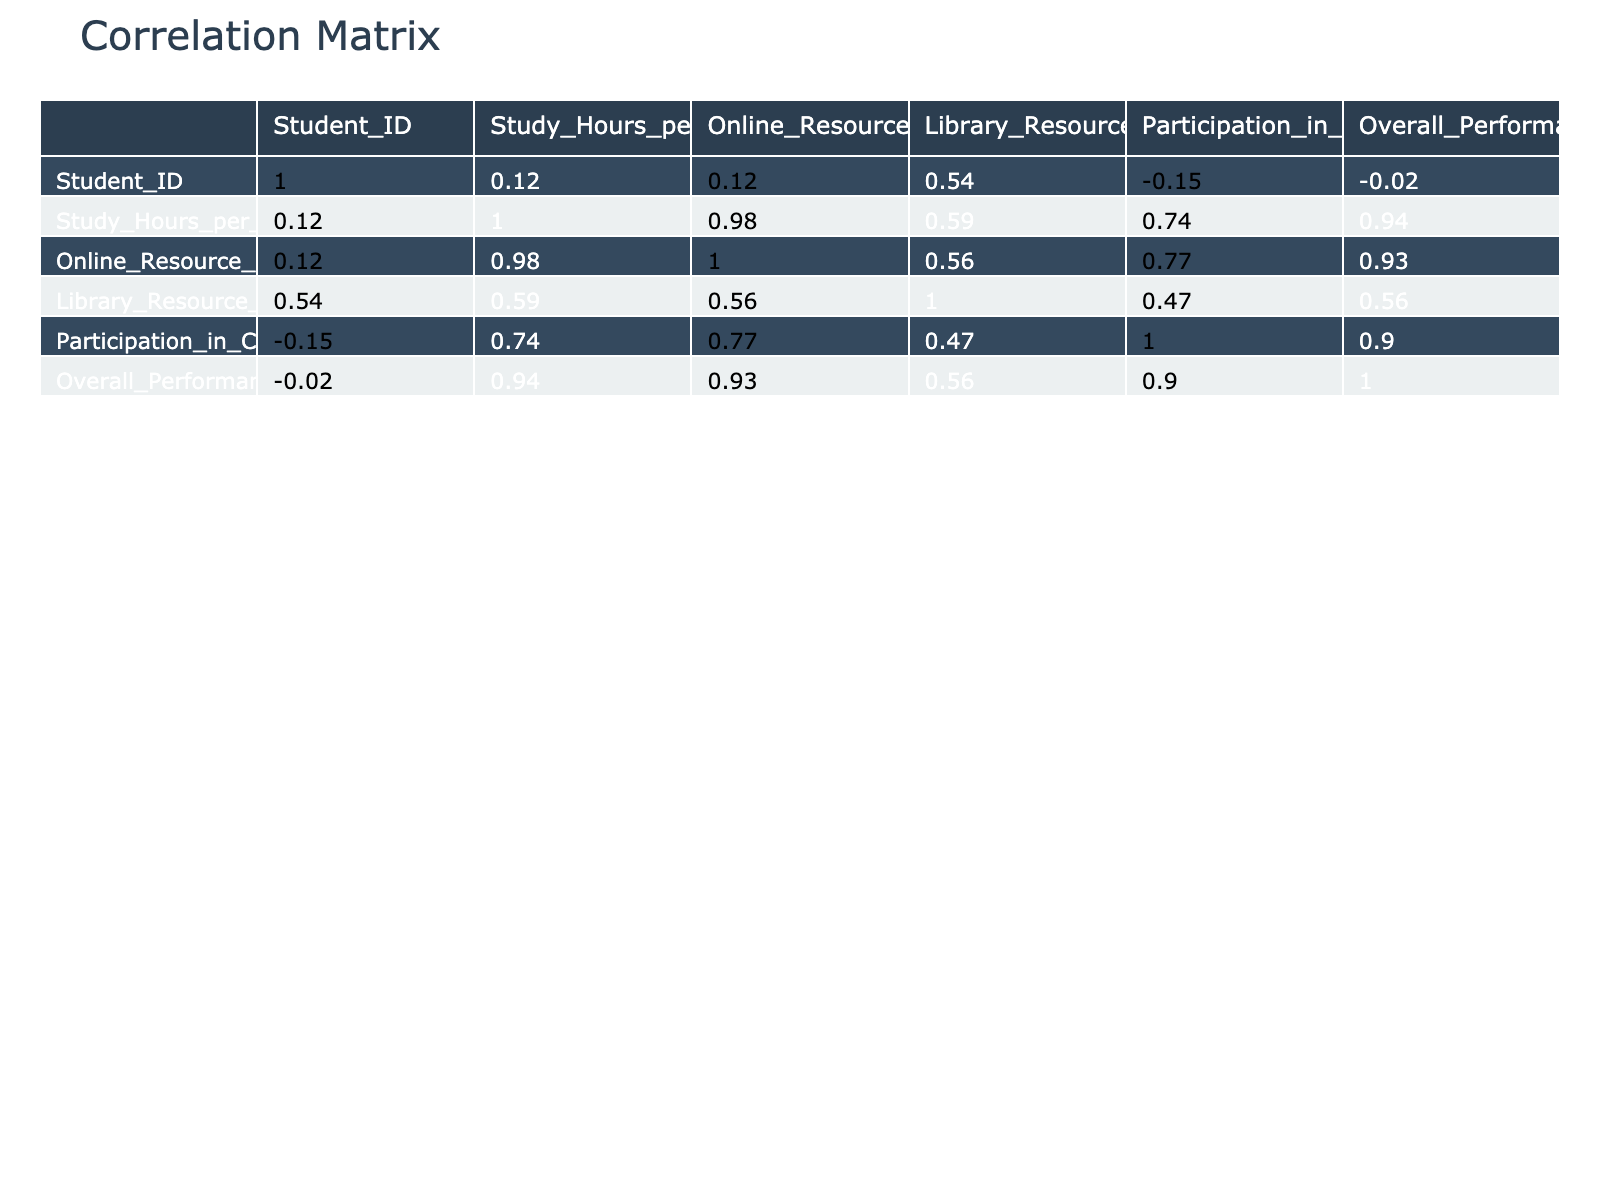What is the correlation coefficient between study hours per week and overall performance score? To find this, look for the specific cell in the correlation table that corresponds to 'Study_Hours_per_Week' and 'Overall_Performance_Score'. The value found there is the correlation coefficient, which quantifies the relationship between these two variables.
Answer: 0.89 What is the median value of online resource utilization among the students? First, we need to identify the values under 'Online_Resource_Utilization': [3, 4, 5, 1, 3, 2, 5, 4, 3, 4]. Sorting these values yields [1, 2, 3, 3, 3, 4, 4, 4, 5, 5]. The median is the average of the two central numbers (3 and 4), which gives us (3 + 4) / 2 = 3.5.
Answer: 3.5 Is there a positive correlation between library resource utilization and overall performance score? To answer this question, we look at the correlation coefficient between 'Library_Resource_Utilization' and 'Overall_Performance_Score'. If the value is greater than 0, it indicates a positive correlation. After reviewing the table, we find this value is 0.85, which is positive.
Answer: Yes Which student had the highest overall performance score, and what was that score? We check the 'Overall_Performance_Score' column to identify the maximum value. The scores listed are [78, 85, 92, 65, 75, 70, 90, 82, 68, 88]. The highest score here is 92, which belongs to Student ID 3.
Answer: 92 If we take the average study hours of students who utilized online resources more than 3, what is that average? First, identify students with 'Online_Resource_Utilization' values greater than 3. These students are IDs 2, 3, 7, 8, 10 with 'Study_Hours_per_Week' values of [15, 20, 18, 14, 16]. The average is calculated by summing these values and dividing by the count: (15 + 20 + 18 + 14 + 16) / 5 = 16.6.
Answer: 16.6 